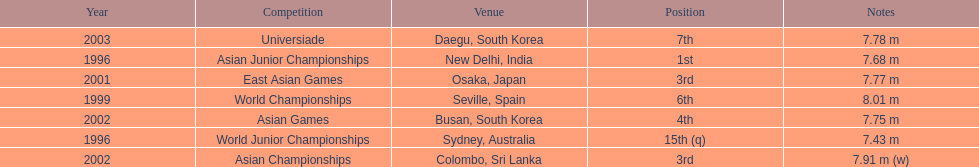What is the difference between the number of times the position of third was achieved and the number of times the position of first was achieved? 1. 